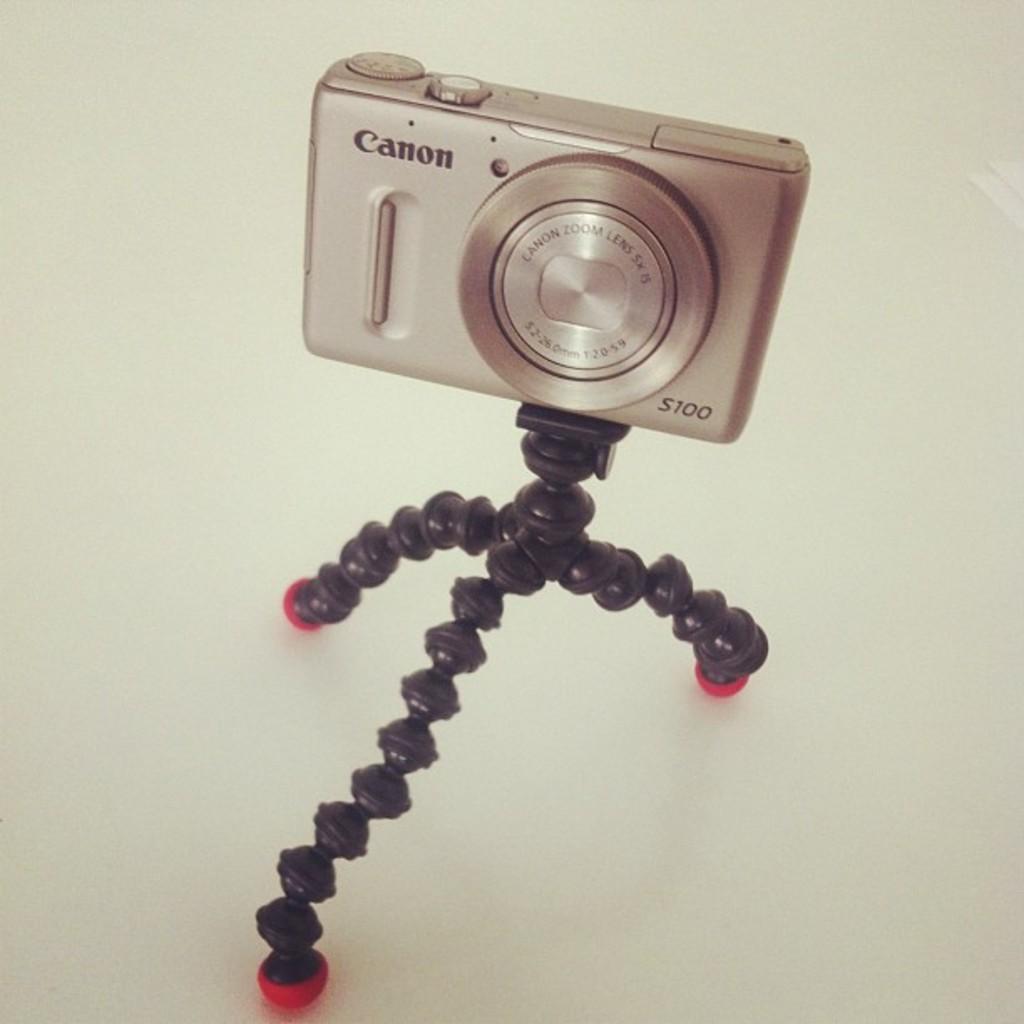Could you give a brief overview of what you see in this image? In this image in the center there is a camera on the stand which is black in colour and there is some text written on the camera. 